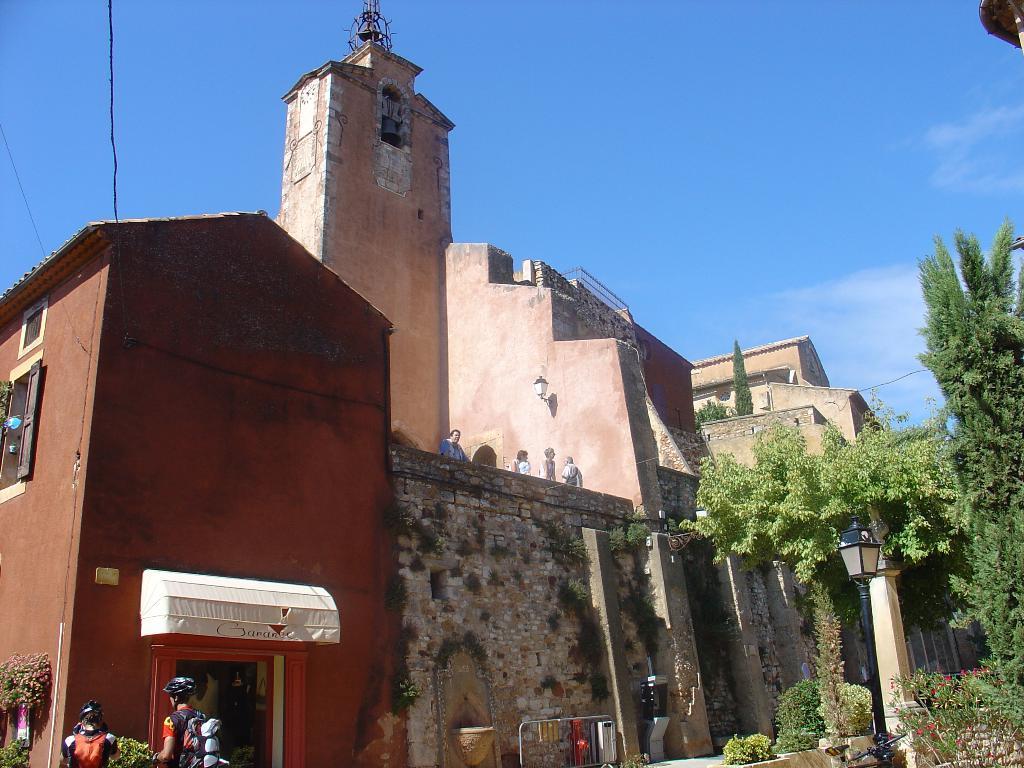Can you describe this image briefly? In this image, we can see buildings, trees, a window, some plants, some people wearing coats, bags and helmets and some are standing on the building and there is a railing and we can see some other objects and there is a light. At the top, there is sky. 